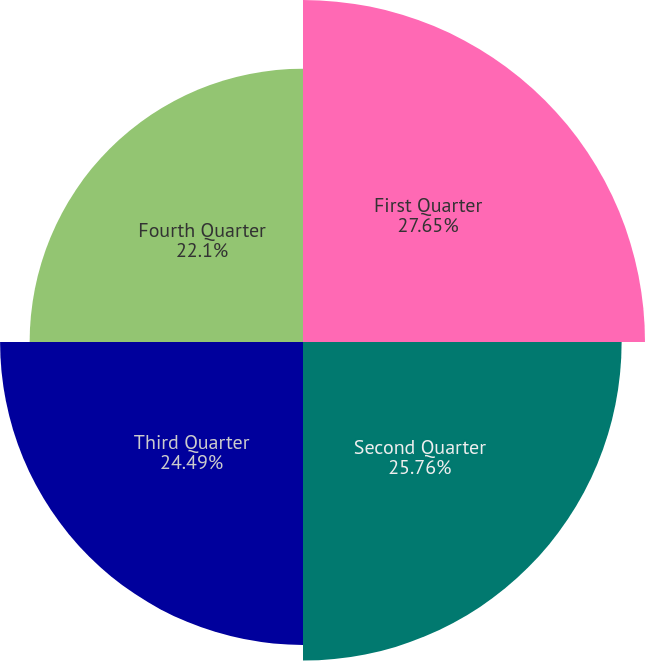Convert chart to OTSL. <chart><loc_0><loc_0><loc_500><loc_500><pie_chart><fcel>First Quarter<fcel>Second Quarter<fcel>Third Quarter<fcel>Fourth Quarter<nl><fcel>27.65%<fcel>25.76%<fcel>24.49%<fcel>22.1%<nl></chart> 